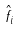Convert formula to latex. <formula><loc_0><loc_0><loc_500><loc_500>\hat { f } _ { i }</formula> 